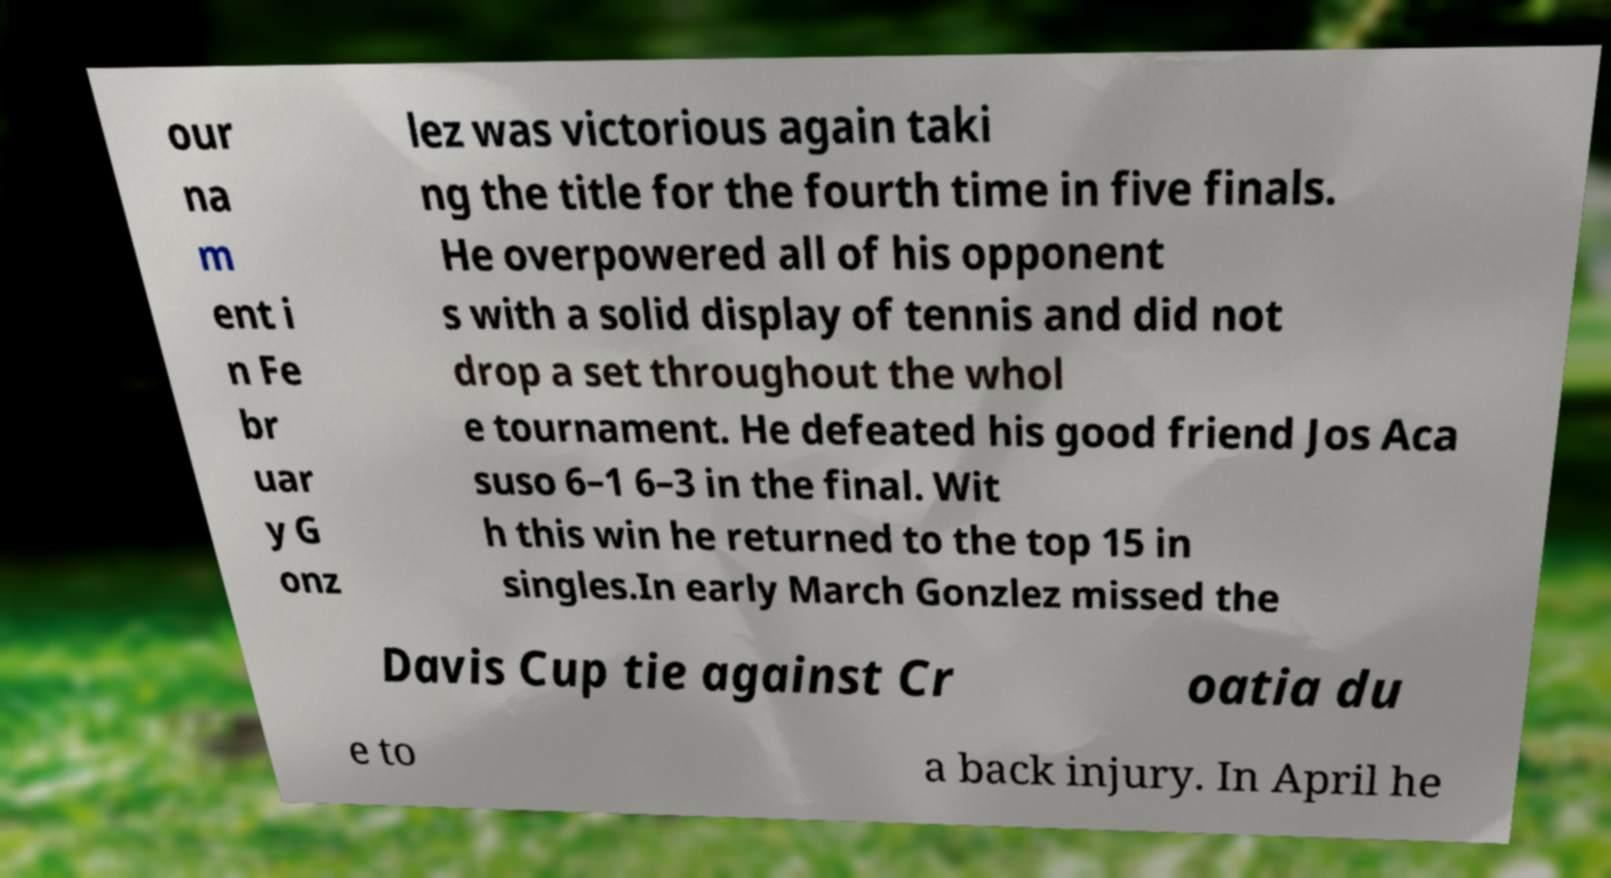Could you assist in decoding the text presented in this image and type it out clearly? our na m ent i n Fe br uar y G onz lez was victorious again taki ng the title for the fourth time in five finals. He overpowered all of his opponent s with a solid display of tennis and did not drop a set throughout the whol e tournament. He defeated his good friend Jos Aca suso 6–1 6–3 in the final. Wit h this win he returned to the top 15 in singles.In early March Gonzlez missed the Davis Cup tie against Cr oatia du e to a back injury. In April he 